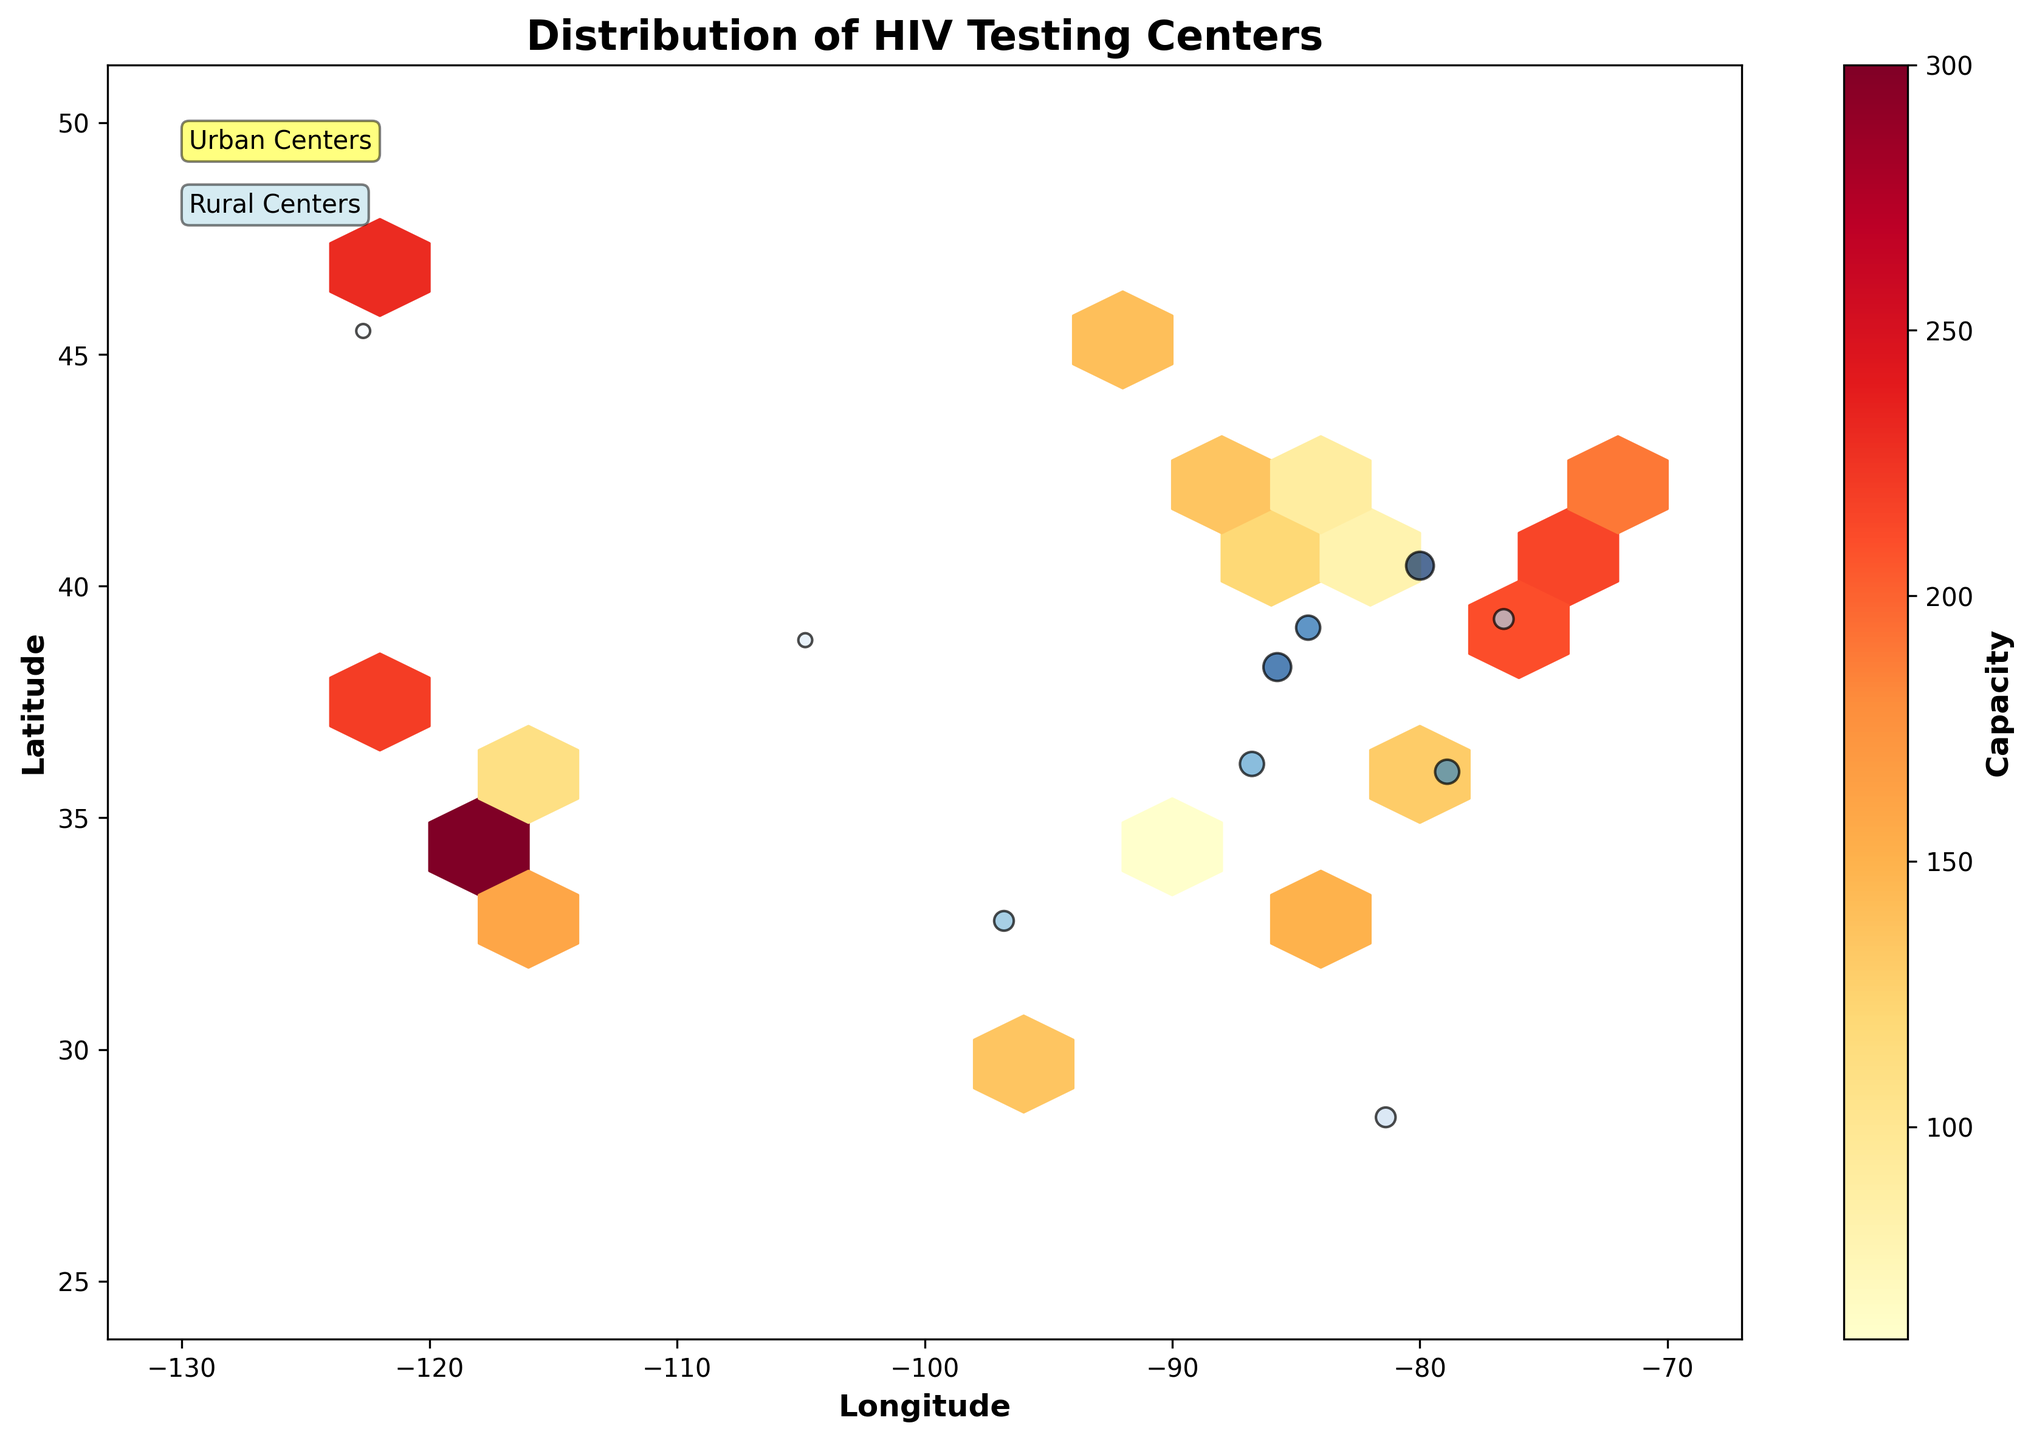What is the title of the plot? The title of the plot is typically located at the top of the figure. It provides a quick summary of what the figure represents. Here, it reads "Distribution of HIV Testing Centers".
Answer: Distribution of HIV Testing Centers What does the color bar represent in the plot? The color bar usually indicates the meaning of the color scale used in the plot. In this figure, the color bar represents the 'Capacity' of HIV testing centers.
Answer: Capacity How is accessibility visually represented for rural centers? Accessibility for rural centers is depicted by the size of the scatter plot markers. Larger markers indicate higher accessibility.
Answer: Size of markers Are the HIV testing centers more densely located in urban or rural areas? From the hexbin plot for urban centers and scattered points for rural centers, it is evident that there are more centers densely located in urban areas. This is seen by the dense and widespread hexagons versus scattered rural points.
Answer: Urban areas Which urban area seems to have the highest capacity HIV testing center? By observing the color gradient in the hexbin plot, the brighter yellow or red hexagons indicate higher capacities. The center with the most intense color is around 34.0522 latitude and -118.2437 longitude, representing Los Angeles.
Answer: Los Angeles How does the capacity distribution differ between urban and rural areas? Urban areas have a range of capacities represented by varying color intensities in the hexbin plot. Rural areas have distinctly separate points with smaller, less intense circles, indicating lower capacities and fewer overall centers. This difference is apparent when comparing the hexagon colors to the scatter plot points.
Answer: Urban areas have higher and more varied capacities What is the color used to highlight rural centers in the plot? The rural centers are highlighted using a light blue color within the scatter plot markers, making them distinct from urban centers.
Answer: Light blue Are there any urban areas with a capacity of 50 or less? From the color bar, areas with a lower capacity would be closer to the lighter colors (ranging to yellows in the color map). It is visible that no hexagons in the urban areas have colors indicating a capacity as low as 50 or less.
Answer: No Which urban center has the second highest accessibility, and what is its capacity? By locating centers with the highest accessibility using the marker size for rural points and the color intensity for urban, the second highest accessibility can be identified after Los Angeles. This center is located around 38.9072 latitude and -77.0369 longitude, representing Washington D.C., with a capacity of approximately 210.
Answer: Washington D.C., 210 